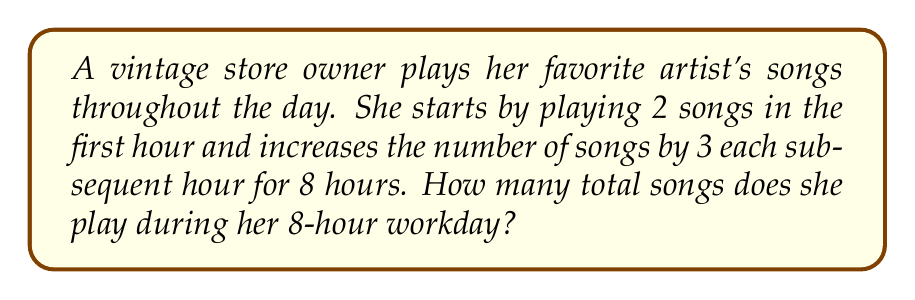Give your solution to this math problem. Let's approach this step-by-step:

1) This situation represents an arithmetic sequence, where:
   - First term, $a_1 = 2$ (songs in the first hour)
   - Common difference, $d = 3$ (increase each hour)
   - Number of terms, $n = 8$ (8-hour workday)

2) The arithmetic sequence formula for the sum is:

   $$S_n = \frac{n}{2}(a_1 + a_n)$$

   Where $a_n$ is the last term.

3) To find $a_n$, we use the arithmetic sequence term formula:
   
   $$a_n = a_1 + (n-1)d$$
   $$a_8 = 2 + (8-1)3 = 2 + 21 = 23$$

4) Now we can substitute into our sum formula:

   $$S_8 = \frac{8}{2}(2 + 23)$$

5) Simplify:
   
   $$S_8 = 4(25) = 100$$

Therefore, the vintage store owner plays a total of 100 songs during her 8-hour workday.
Answer: 100 songs 